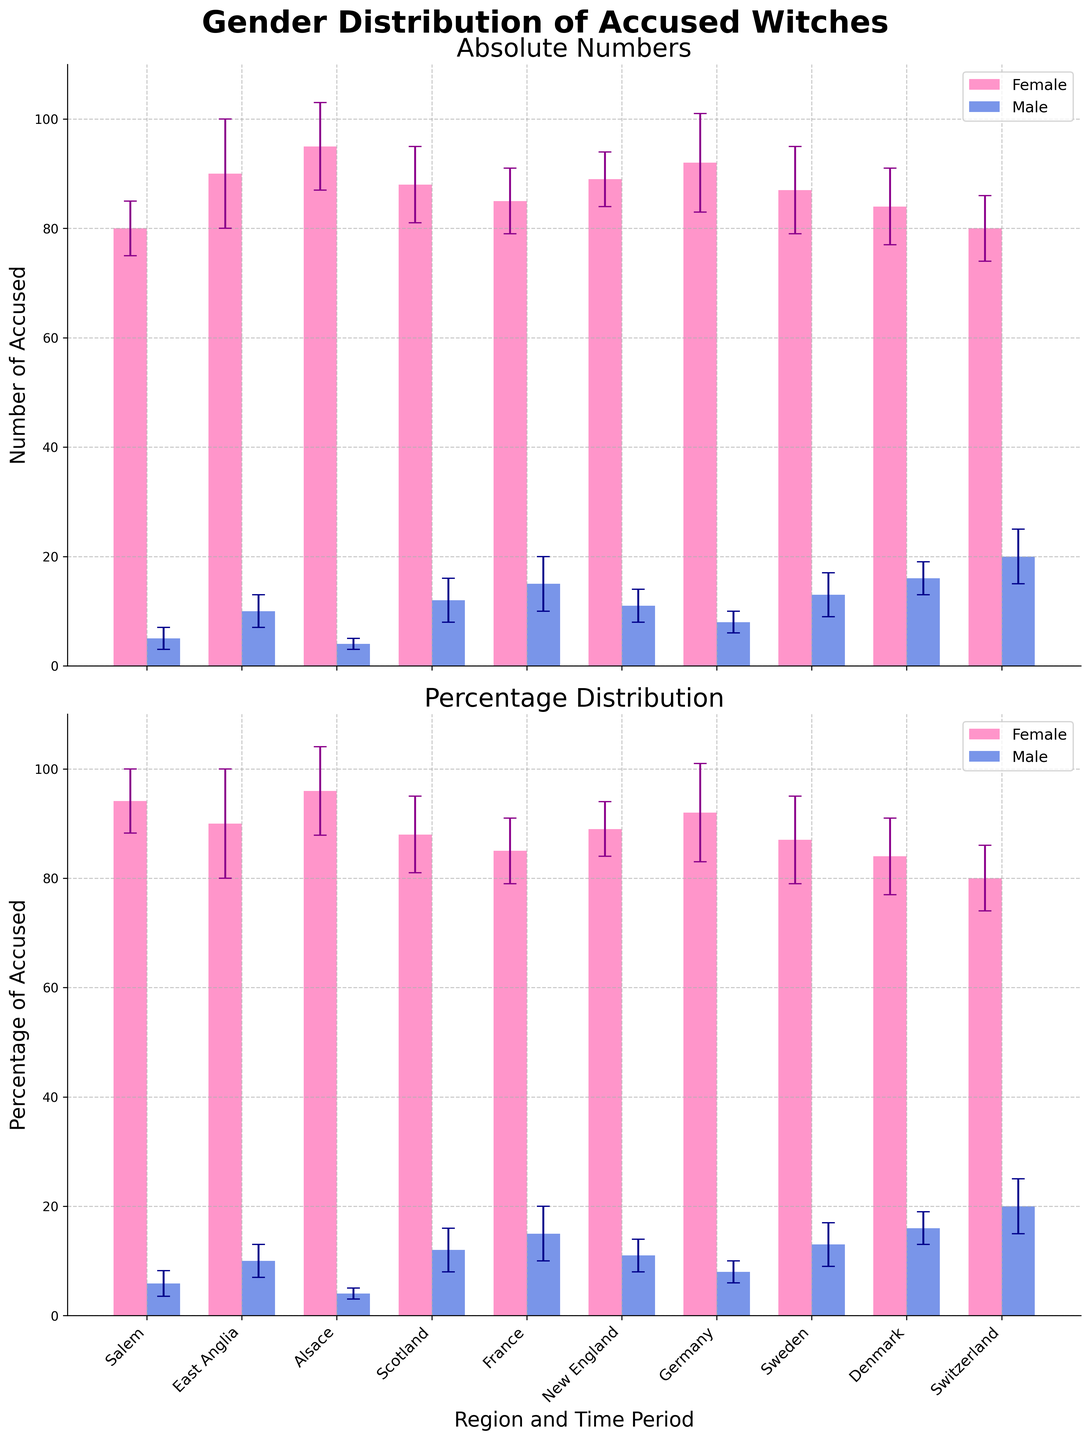What is the title of the figure? The title is displayed at the top of the figure, prominently centered, indicating the primary subject of the visualization.
Answer: Gender Distribution of Accused Witches Which region has the highest number of female accused witches? By comparing the heights of the bars in the upper subplot, the 'Alsace' region has the tallest bar for female accused witches.
Answer: Alsace What is the total number of accused witches in Salem? By summing the females (80) and males (5) accused witches in Salem, we get the total number.
Answer: 85 Which time period or region shows the greatest uncertainty for male accused witches? The error bars in the upper subplot for males show that 'France' has the largest error margin for male accused witches (5).
Answer: France What is the percentage of male accused witches in Switzerland? Using the lower subplot, the male percentage bar for Switzerland shows a value of approximately 20%.
Answer: ~20% Comparing the absolute numbers, which region has a higher number of male accused witches: Denmark or Scotland? Checking the heights of the male bars in the upper subplot, Denmark has 16 males, while Scotland has 12 males.
Answer: Denmark Among the regions listed, which had the least number of female accused witches? The upper subplot shows that 'Salem' has the lowest female accused witches bar (80).
Answer: Salem What is the difference in the percentage of female accused witches between East Anglia and New England? From the lower subplot, East Anglia's female percentage is approximately 90%, and New England's is about 89%. The difference is about 1%.
Answer: ~1% Which region shows a more balanced gender distribution in absolute numbers? In the upper subplot, Switzerland has closer numbers of female (80) and male (20) accused witches, suggesting a more balanced distribution compared to other regions.
Answer: Switzerland What error margin is associated with the percentage of male accused witches in East Anglia? The error bar of the male percentage bar for East Anglia in the lower subplot is approximately 3%.
Answer: ~3% 